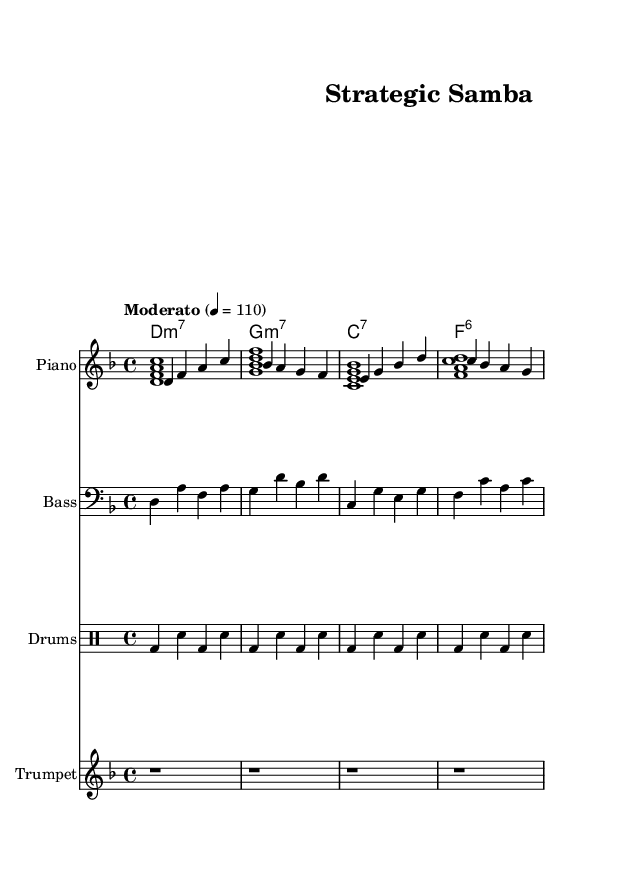What is the key signature of this music? The key signature is indicated at the beginning of the staff and shows two flats, which correspond to B-flat and E-flat. This establishes the piece as being in D minor.
Answer: D minor What is the time signature of this music? The time signature is displayed at the beginning of the staff. It shows the top number as 4, indicating four beats per measure, and the bottom number as 4, indicating a quarter note gets one beat.
Answer: 4/4 What is the tempo marking for this piece? The tempo marking appears just above the staff and indicates "Moderato" at a metronome marking of 110 beats per minute, which suggests a moderate pace for the music.
Answer: Moderato 4 = 110 How many measures are in the melody section? The melody section is visually structured into four measures, each separated by vertical lines. Counting these lines leads to the total number of measures present in the melody.
Answer: 4 What type of chord is used in the first measure? The first measure contains a chord labeled "d:m7," which indicates it is a D minor seventh chord consisting of D, F, A, and C.
Answer: D minor seventh What rhythmic pattern is used in the drums? The drum part exhibits a pattern with a kick drum on beats 1 and 3, and a snare drum on beats 2 and 4, repeated four times to establish the basis for the rhythm.
Answer: Kick-snare pattern What unique characteristic of Latin music is reflected in this piece? The piece employs syncopation and a lively rhythm typical of Latin styles, which adds to its energetic feel and makes it suitable for gaming backgrounds.
Answer: Syncopation 